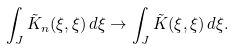Convert formula to latex. <formula><loc_0><loc_0><loc_500><loc_500>\int _ { J } \tilde { K } _ { n } ( \xi , \xi ) \, d \xi \to \int _ { J } \tilde { K } ( \xi , \xi ) \, d \xi .</formula> 